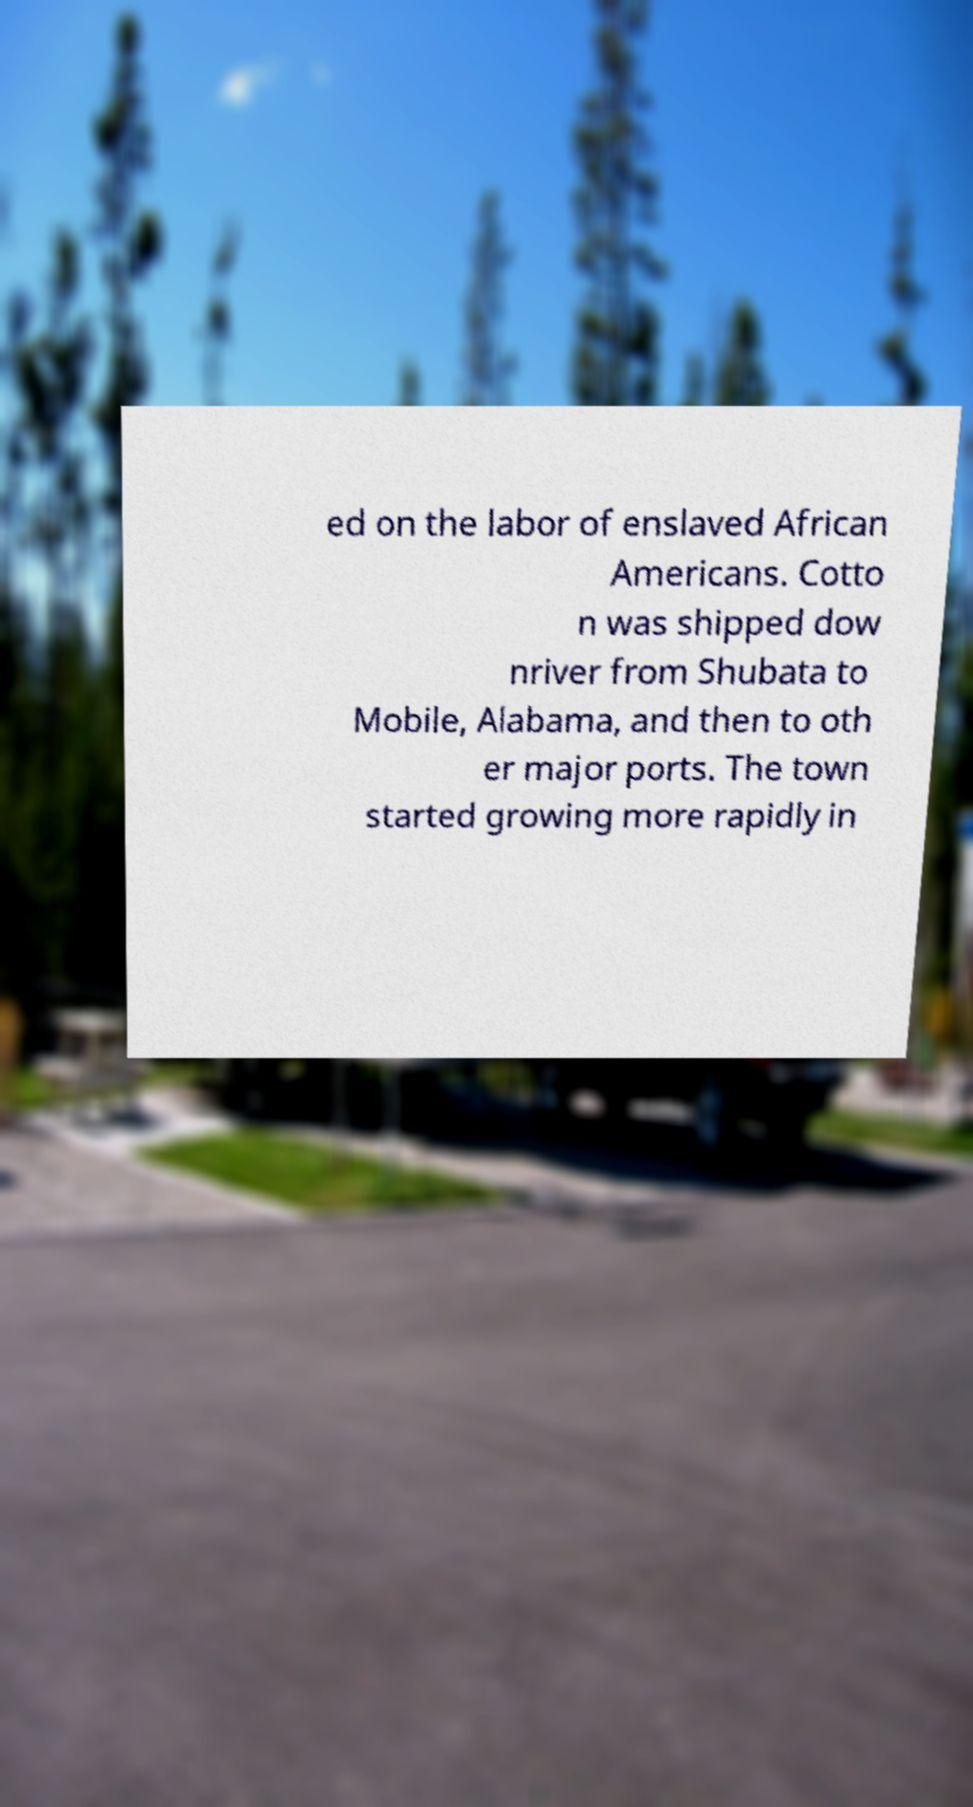I need the written content from this picture converted into text. Can you do that? ed on the labor of enslaved African Americans. Cotto n was shipped dow nriver from Shubata to Mobile, Alabama, and then to oth er major ports. The town started growing more rapidly in 